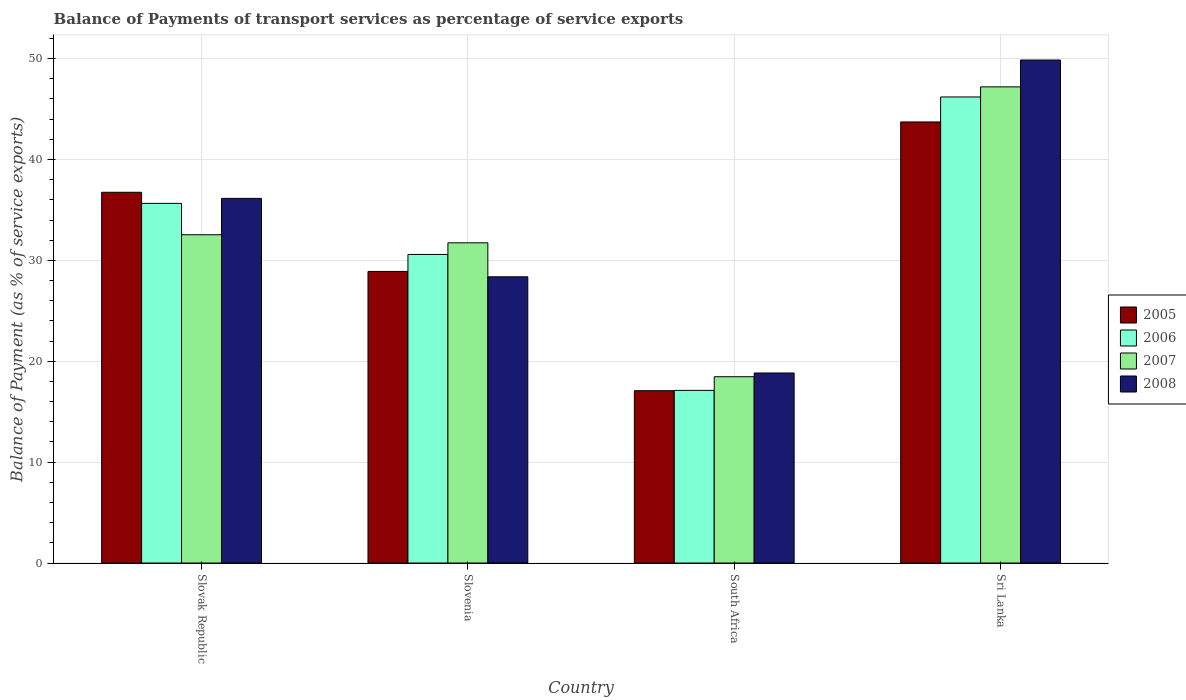How many different coloured bars are there?
Provide a succinct answer. 4. How many groups of bars are there?
Your answer should be compact. 4. What is the label of the 2nd group of bars from the left?
Your answer should be compact. Slovenia. In how many cases, is the number of bars for a given country not equal to the number of legend labels?
Offer a very short reply. 0. What is the balance of payments of transport services in 2005 in Sri Lanka?
Keep it short and to the point. 43.72. Across all countries, what is the maximum balance of payments of transport services in 2006?
Give a very brief answer. 46.2. Across all countries, what is the minimum balance of payments of transport services in 2005?
Your answer should be very brief. 17.08. In which country was the balance of payments of transport services in 2006 maximum?
Your response must be concise. Sri Lanka. In which country was the balance of payments of transport services in 2006 minimum?
Your answer should be compact. South Africa. What is the total balance of payments of transport services in 2007 in the graph?
Offer a very short reply. 129.95. What is the difference between the balance of payments of transport services in 2007 in Slovenia and that in South Africa?
Offer a very short reply. 13.27. What is the difference between the balance of payments of transport services in 2007 in Slovenia and the balance of payments of transport services in 2006 in Slovak Republic?
Make the answer very short. -3.91. What is the average balance of payments of transport services in 2006 per country?
Offer a terse response. 32.39. What is the difference between the balance of payments of transport services of/in 2008 and balance of payments of transport services of/in 2005 in Sri Lanka?
Ensure brevity in your answer.  6.14. In how many countries, is the balance of payments of transport services in 2008 greater than 16 %?
Your answer should be compact. 4. What is the ratio of the balance of payments of transport services in 2005 in Slovak Republic to that in South Africa?
Provide a succinct answer. 2.15. Is the balance of payments of transport services in 2007 in South Africa less than that in Sri Lanka?
Your answer should be compact. Yes. What is the difference between the highest and the second highest balance of payments of transport services in 2005?
Offer a very short reply. 6.97. What is the difference between the highest and the lowest balance of payments of transport services in 2007?
Your response must be concise. 28.73. In how many countries, is the balance of payments of transport services in 2008 greater than the average balance of payments of transport services in 2008 taken over all countries?
Your answer should be very brief. 2. Is the sum of the balance of payments of transport services in 2008 in Slovak Republic and Sri Lanka greater than the maximum balance of payments of transport services in 2005 across all countries?
Offer a terse response. Yes. Is it the case that in every country, the sum of the balance of payments of transport services in 2005 and balance of payments of transport services in 2008 is greater than the sum of balance of payments of transport services in 2006 and balance of payments of transport services in 2007?
Provide a succinct answer. No. What does the 1st bar from the left in Slovak Republic represents?
Ensure brevity in your answer.  2005. What does the 2nd bar from the right in Slovak Republic represents?
Your response must be concise. 2007. Is it the case that in every country, the sum of the balance of payments of transport services in 2006 and balance of payments of transport services in 2005 is greater than the balance of payments of transport services in 2008?
Your answer should be very brief. Yes. Does the graph contain any zero values?
Ensure brevity in your answer.  No. Where does the legend appear in the graph?
Keep it short and to the point. Center right. How many legend labels are there?
Offer a very short reply. 4. What is the title of the graph?
Your response must be concise. Balance of Payments of transport services as percentage of service exports. What is the label or title of the Y-axis?
Make the answer very short. Balance of Payment (as % of service exports). What is the Balance of Payment (as % of service exports) of 2005 in Slovak Republic?
Give a very brief answer. 36.75. What is the Balance of Payment (as % of service exports) in 2006 in Slovak Republic?
Offer a very short reply. 35.65. What is the Balance of Payment (as % of service exports) of 2007 in Slovak Republic?
Provide a succinct answer. 32.54. What is the Balance of Payment (as % of service exports) of 2008 in Slovak Republic?
Ensure brevity in your answer.  36.14. What is the Balance of Payment (as % of service exports) of 2005 in Slovenia?
Your answer should be very brief. 28.9. What is the Balance of Payment (as % of service exports) of 2006 in Slovenia?
Give a very brief answer. 30.59. What is the Balance of Payment (as % of service exports) in 2007 in Slovenia?
Make the answer very short. 31.74. What is the Balance of Payment (as % of service exports) of 2008 in Slovenia?
Ensure brevity in your answer.  28.37. What is the Balance of Payment (as % of service exports) in 2005 in South Africa?
Provide a succinct answer. 17.08. What is the Balance of Payment (as % of service exports) in 2006 in South Africa?
Give a very brief answer. 17.11. What is the Balance of Payment (as % of service exports) in 2007 in South Africa?
Give a very brief answer. 18.47. What is the Balance of Payment (as % of service exports) of 2008 in South Africa?
Provide a short and direct response. 18.84. What is the Balance of Payment (as % of service exports) of 2005 in Sri Lanka?
Keep it short and to the point. 43.72. What is the Balance of Payment (as % of service exports) of 2006 in Sri Lanka?
Offer a terse response. 46.2. What is the Balance of Payment (as % of service exports) of 2007 in Sri Lanka?
Ensure brevity in your answer.  47.2. What is the Balance of Payment (as % of service exports) in 2008 in Sri Lanka?
Give a very brief answer. 49.86. Across all countries, what is the maximum Balance of Payment (as % of service exports) in 2005?
Your response must be concise. 43.72. Across all countries, what is the maximum Balance of Payment (as % of service exports) in 2006?
Your answer should be compact. 46.2. Across all countries, what is the maximum Balance of Payment (as % of service exports) of 2007?
Provide a succinct answer. 47.2. Across all countries, what is the maximum Balance of Payment (as % of service exports) in 2008?
Provide a succinct answer. 49.86. Across all countries, what is the minimum Balance of Payment (as % of service exports) of 2005?
Offer a very short reply. 17.08. Across all countries, what is the minimum Balance of Payment (as % of service exports) of 2006?
Your response must be concise. 17.11. Across all countries, what is the minimum Balance of Payment (as % of service exports) in 2007?
Your answer should be compact. 18.47. Across all countries, what is the minimum Balance of Payment (as % of service exports) in 2008?
Provide a short and direct response. 18.84. What is the total Balance of Payment (as % of service exports) in 2005 in the graph?
Your response must be concise. 126.46. What is the total Balance of Payment (as % of service exports) in 2006 in the graph?
Ensure brevity in your answer.  129.55. What is the total Balance of Payment (as % of service exports) of 2007 in the graph?
Keep it short and to the point. 129.95. What is the total Balance of Payment (as % of service exports) in 2008 in the graph?
Your answer should be very brief. 133.21. What is the difference between the Balance of Payment (as % of service exports) in 2005 in Slovak Republic and that in Slovenia?
Your answer should be compact. 7.85. What is the difference between the Balance of Payment (as % of service exports) in 2006 in Slovak Republic and that in Slovenia?
Offer a very short reply. 5.06. What is the difference between the Balance of Payment (as % of service exports) of 2007 in Slovak Republic and that in Slovenia?
Offer a terse response. 0.8. What is the difference between the Balance of Payment (as % of service exports) in 2008 in Slovak Republic and that in Slovenia?
Give a very brief answer. 7.77. What is the difference between the Balance of Payment (as % of service exports) of 2005 in Slovak Republic and that in South Africa?
Keep it short and to the point. 19.67. What is the difference between the Balance of Payment (as % of service exports) of 2006 in Slovak Republic and that in South Africa?
Provide a short and direct response. 18.54. What is the difference between the Balance of Payment (as % of service exports) of 2007 in Slovak Republic and that in South Africa?
Give a very brief answer. 14.07. What is the difference between the Balance of Payment (as % of service exports) in 2008 in Slovak Republic and that in South Africa?
Offer a very short reply. 17.31. What is the difference between the Balance of Payment (as % of service exports) in 2005 in Slovak Republic and that in Sri Lanka?
Your answer should be very brief. -6.97. What is the difference between the Balance of Payment (as % of service exports) in 2006 in Slovak Republic and that in Sri Lanka?
Offer a terse response. -10.55. What is the difference between the Balance of Payment (as % of service exports) in 2007 in Slovak Republic and that in Sri Lanka?
Keep it short and to the point. -14.66. What is the difference between the Balance of Payment (as % of service exports) of 2008 in Slovak Republic and that in Sri Lanka?
Your response must be concise. -13.72. What is the difference between the Balance of Payment (as % of service exports) in 2005 in Slovenia and that in South Africa?
Give a very brief answer. 11.82. What is the difference between the Balance of Payment (as % of service exports) in 2006 in Slovenia and that in South Africa?
Keep it short and to the point. 13.47. What is the difference between the Balance of Payment (as % of service exports) of 2007 in Slovenia and that in South Africa?
Ensure brevity in your answer.  13.27. What is the difference between the Balance of Payment (as % of service exports) in 2008 in Slovenia and that in South Africa?
Your response must be concise. 9.53. What is the difference between the Balance of Payment (as % of service exports) in 2005 in Slovenia and that in Sri Lanka?
Provide a succinct answer. -14.82. What is the difference between the Balance of Payment (as % of service exports) of 2006 in Slovenia and that in Sri Lanka?
Keep it short and to the point. -15.61. What is the difference between the Balance of Payment (as % of service exports) of 2007 in Slovenia and that in Sri Lanka?
Give a very brief answer. -15.46. What is the difference between the Balance of Payment (as % of service exports) of 2008 in Slovenia and that in Sri Lanka?
Your answer should be very brief. -21.49. What is the difference between the Balance of Payment (as % of service exports) of 2005 in South Africa and that in Sri Lanka?
Ensure brevity in your answer.  -26.64. What is the difference between the Balance of Payment (as % of service exports) in 2006 in South Africa and that in Sri Lanka?
Your answer should be compact. -29.09. What is the difference between the Balance of Payment (as % of service exports) in 2007 in South Africa and that in Sri Lanka?
Give a very brief answer. -28.73. What is the difference between the Balance of Payment (as % of service exports) in 2008 in South Africa and that in Sri Lanka?
Ensure brevity in your answer.  -31.02. What is the difference between the Balance of Payment (as % of service exports) in 2005 in Slovak Republic and the Balance of Payment (as % of service exports) in 2006 in Slovenia?
Make the answer very short. 6.16. What is the difference between the Balance of Payment (as % of service exports) in 2005 in Slovak Republic and the Balance of Payment (as % of service exports) in 2007 in Slovenia?
Your response must be concise. 5.01. What is the difference between the Balance of Payment (as % of service exports) in 2005 in Slovak Republic and the Balance of Payment (as % of service exports) in 2008 in Slovenia?
Give a very brief answer. 8.38. What is the difference between the Balance of Payment (as % of service exports) in 2006 in Slovak Republic and the Balance of Payment (as % of service exports) in 2007 in Slovenia?
Your response must be concise. 3.91. What is the difference between the Balance of Payment (as % of service exports) in 2006 in Slovak Republic and the Balance of Payment (as % of service exports) in 2008 in Slovenia?
Provide a short and direct response. 7.28. What is the difference between the Balance of Payment (as % of service exports) of 2007 in Slovak Republic and the Balance of Payment (as % of service exports) of 2008 in Slovenia?
Make the answer very short. 4.17. What is the difference between the Balance of Payment (as % of service exports) in 2005 in Slovak Republic and the Balance of Payment (as % of service exports) in 2006 in South Africa?
Provide a succinct answer. 19.64. What is the difference between the Balance of Payment (as % of service exports) of 2005 in Slovak Republic and the Balance of Payment (as % of service exports) of 2007 in South Africa?
Ensure brevity in your answer.  18.28. What is the difference between the Balance of Payment (as % of service exports) of 2005 in Slovak Republic and the Balance of Payment (as % of service exports) of 2008 in South Africa?
Provide a short and direct response. 17.91. What is the difference between the Balance of Payment (as % of service exports) in 2006 in Slovak Republic and the Balance of Payment (as % of service exports) in 2007 in South Africa?
Offer a terse response. 17.18. What is the difference between the Balance of Payment (as % of service exports) of 2006 in Slovak Republic and the Balance of Payment (as % of service exports) of 2008 in South Africa?
Provide a short and direct response. 16.81. What is the difference between the Balance of Payment (as % of service exports) in 2007 in Slovak Republic and the Balance of Payment (as % of service exports) in 2008 in South Africa?
Make the answer very short. 13.71. What is the difference between the Balance of Payment (as % of service exports) in 2005 in Slovak Republic and the Balance of Payment (as % of service exports) in 2006 in Sri Lanka?
Your answer should be compact. -9.45. What is the difference between the Balance of Payment (as % of service exports) of 2005 in Slovak Republic and the Balance of Payment (as % of service exports) of 2007 in Sri Lanka?
Make the answer very short. -10.45. What is the difference between the Balance of Payment (as % of service exports) of 2005 in Slovak Republic and the Balance of Payment (as % of service exports) of 2008 in Sri Lanka?
Your response must be concise. -13.11. What is the difference between the Balance of Payment (as % of service exports) of 2006 in Slovak Republic and the Balance of Payment (as % of service exports) of 2007 in Sri Lanka?
Make the answer very short. -11.55. What is the difference between the Balance of Payment (as % of service exports) of 2006 in Slovak Republic and the Balance of Payment (as % of service exports) of 2008 in Sri Lanka?
Provide a succinct answer. -14.21. What is the difference between the Balance of Payment (as % of service exports) of 2007 in Slovak Republic and the Balance of Payment (as % of service exports) of 2008 in Sri Lanka?
Offer a very short reply. -17.32. What is the difference between the Balance of Payment (as % of service exports) in 2005 in Slovenia and the Balance of Payment (as % of service exports) in 2006 in South Africa?
Make the answer very short. 11.79. What is the difference between the Balance of Payment (as % of service exports) in 2005 in Slovenia and the Balance of Payment (as % of service exports) in 2007 in South Africa?
Offer a very short reply. 10.44. What is the difference between the Balance of Payment (as % of service exports) in 2005 in Slovenia and the Balance of Payment (as % of service exports) in 2008 in South Africa?
Make the answer very short. 10.07. What is the difference between the Balance of Payment (as % of service exports) of 2006 in Slovenia and the Balance of Payment (as % of service exports) of 2007 in South Africa?
Your answer should be compact. 12.12. What is the difference between the Balance of Payment (as % of service exports) in 2006 in Slovenia and the Balance of Payment (as % of service exports) in 2008 in South Africa?
Make the answer very short. 11.75. What is the difference between the Balance of Payment (as % of service exports) of 2007 in Slovenia and the Balance of Payment (as % of service exports) of 2008 in South Africa?
Provide a short and direct response. 12.9. What is the difference between the Balance of Payment (as % of service exports) in 2005 in Slovenia and the Balance of Payment (as % of service exports) in 2006 in Sri Lanka?
Offer a terse response. -17.3. What is the difference between the Balance of Payment (as % of service exports) of 2005 in Slovenia and the Balance of Payment (as % of service exports) of 2007 in Sri Lanka?
Ensure brevity in your answer.  -18.3. What is the difference between the Balance of Payment (as % of service exports) in 2005 in Slovenia and the Balance of Payment (as % of service exports) in 2008 in Sri Lanka?
Provide a succinct answer. -20.96. What is the difference between the Balance of Payment (as % of service exports) of 2006 in Slovenia and the Balance of Payment (as % of service exports) of 2007 in Sri Lanka?
Ensure brevity in your answer.  -16.61. What is the difference between the Balance of Payment (as % of service exports) in 2006 in Slovenia and the Balance of Payment (as % of service exports) in 2008 in Sri Lanka?
Make the answer very short. -19.27. What is the difference between the Balance of Payment (as % of service exports) in 2007 in Slovenia and the Balance of Payment (as % of service exports) in 2008 in Sri Lanka?
Keep it short and to the point. -18.12. What is the difference between the Balance of Payment (as % of service exports) in 2005 in South Africa and the Balance of Payment (as % of service exports) in 2006 in Sri Lanka?
Your answer should be very brief. -29.12. What is the difference between the Balance of Payment (as % of service exports) of 2005 in South Africa and the Balance of Payment (as % of service exports) of 2007 in Sri Lanka?
Your response must be concise. -30.12. What is the difference between the Balance of Payment (as % of service exports) in 2005 in South Africa and the Balance of Payment (as % of service exports) in 2008 in Sri Lanka?
Give a very brief answer. -32.78. What is the difference between the Balance of Payment (as % of service exports) in 2006 in South Africa and the Balance of Payment (as % of service exports) in 2007 in Sri Lanka?
Offer a terse response. -30.09. What is the difference between the Balance of Payment (as % of service exports) in 2006 in South Africa and the Balance of Payment (as % of service exports) in 2008 in Sri Lanka?
Provide a short and direct response. -32.75. What is the difference between the Balance of Payment (as % of service exports) of 2007 in South Africa and the Balance of Payment (as % of service exports) of 2008 in Sri Lanka?
Offer a terse response. -31.39. What is the average Balance of Payment (as % of service exports) in 2005 per country?
Provide a succinct answer. 31.61. What is the average Balance of Payment (as % of service exports) in 2006 per country?
Give a very brief answer. 32.39. What is the average Balance of Payment (as % of service exports) of 2007 per country?
Provide a succinct answer. 32.49. What is the average Balance of Payment (as % of service exports) of 2008 per country?
Keep it short and to the point. 33.3. What is the difference between the Balance of Payment (as % of service exports) in 2005 and Balance of Payment (as % of service exports) in 2006 in Slovak Republic?
Ensure brevity in your answer.  1.1. What is the difference between the Balance of Payment (as % of service exports) in 2005 and Balance of Payment (as % of service exports) in 2007 in Slovak Republic?
Give a very brief answer. 4.21. What is the difference between the Balance of Payment (as % of service exports) of 2005 and Balance of Payment (as % of service exports) of 2008 in Slovak Republic?
Offer a very short reply. 0.6. What is the difference between the Balance of Payment (as % of service exports) in 2006 and Balance of Payment (as % of service exports) in 2007 in Slovak Republic?
Ensure brevity in your answer.  3.11. What is the difference between the Balance of Payment (as % of service exports) of 2006 and Balance of Payment (as % of service exports) of 2008 in Slovak Republic?
Provide a short and direct response. -0.49. What is the difference between the Balance of Payment (as % of service exports) in 2007 and Balance of Payment (as % of service exports) in 2008 in Slovak Republic?
Make the answer very short. -3.6. What is the difference between the Balance of Payment (as % of service exports) in 2005 and Balance of Payment (as % of service exports) in 2006 in Slovenia?
Your answer should be very brief. -1.69. What is the difference between the Balance of Payment (as % of service exports) in 2005 and Balance of Payment (as % of service exports) in 2007 in Slovenia?
Give a very brief answer. -2.84. What is the difference between the Balance of Payment (as % of service exports) of 2005 and Balance of Payment (as % of service exports) of 2008 in Slovenia?
Your response must be concise. 0.53. What is the difference between the Balance of Payment (as % of service exports) of 2006 and Balance of Payment (as % of service exports) of 2007 in Slovenia?
Offer a very short reply. -1.15. What is the difference between the Balance of Payment (as % of service exports) of 2006 and Balance of Payment (as % of service exports) of 2008 in Slovenia?
Ensure brevity in your answer.  2.22. What is the difference between the Balance of Payment (as % of service exports) in 2007 and Balance of Payment (as % of service exports) in 2008 in Slovenia?
Offer a very short reply. 3.37. What is the difference between the Balance of Payment (as % of service exports) in 2005 and Balance of Payment (as % of service exports) in 2006 in South Africa?
Offer a very short reply. -0.03. What is the difference between the Balance of Payment (as % of service exports) in 2005 and Balance of Payment (as % of service exports) in 2007 in South Africa?
Your answer should be very brief. -1.38. What is the difference between the Balance of Payment (as % of service exports) of 2005 and Balance of Payment (as % of service exports) of 2008 in South Africa?
Ensure brevity in your answer.  -1.75. What is the difference between the Balance of Payment (as % of service exports) of 2006 and Balance of Payment (as % of service exports) of 2007 in South Africa?
Keep it short and to the point. -1.35. What is the difference between the Balance of Payment (as % of service exports) in 2006 and Balance of Payment (as % of service exports) in 2008 in South Africa?
Make the answer very short. -1.72. What is the difference between the Balance of Payment (as % of service exports) of 2007 and Balance of Payment (as % of service exports) of 2008 in South Africa?
Your response must be concise. -0.37. What is the difference between the Balance of Payment (as % of service exports) in 2005 and Balance of Payment (as % of service exports) in 2006 in Sri Lanka?
Make the answer very short. -2.48. What is the difference between the Balance of Payment (as % of service exports) in 2005 and Balance of Payment (as % of service exports) in 2007 in Sri Lanka?
Keep it short and to the point. -3.48. What is the difference between the Balance of Payment (as % of service exports) in 2005 and Balance of Payment (as % of service exports) in 2008 in Sri Lanka?
Provide a short and direct response. -6.14. What is the difference between the Balance of Payment (as % of service exports) in 2006 and Balance of Payment (as % of service exports) in 2007 in Sri Lanka?
Provide a succinct answer. -1. What is the difference between the Balance of Payment (as % of service exports) in 2006 and Balance of Payment (as % of service exports) in 2008 in Sri Lanka?
Ensure brevity in your answer.  -3.66. What is the difference between the Balance of Payment (as % of service exports) of 2007 and Balance of Payment (as % of service exports) of 2008 in Sri Lanka?
Your response must be concise. -2.66. What is the ratio of the Balance of Payment (as % of service exports) of 2005 in Slovak Republic to that in Slovenia?
Provide a short and direct response. 1.27. What is the ratio of the Balance of Payment (as % of service exports) in 2006 in Slovak Republic to that in Slovenia?
Make the answer very short. 1.17. What is the ratio of the Balance of Payment (as % of service exports) of 2007 in Slovak Republic to that in Slovenia?
Your response must be concise. 1.03. What is the ratio of the Balance of Payment (as % of service exports) in 2008 in Slovak Republic to that in Slovenia?
Your answer should be compact. 1.27. What is the ratio of the Balance of Payment (as % of service exports) in 2005 in Slovak Republic to that in South Africa?
Ensure brevity in your answer.  2.15. What is the ratio of the Balance of Payment (as % of service exports) of 2006 in Slovak Republic to that in South Africa?
Provide a short and direct response. 2.08. What is the ratio of the Balance of Payment (as % of service exports) in 2007 in Slovak Republic to that in South Africa?
Offer a very short reply. 1.76. What is the ratio of the Balance of Payment (as % of service exports) of 2008 in Slovak Republic to that in South Africa?
Your answer should be compact. 1.92. What is the ratio of the Balance of Payment (as % of service exports) of 2005 in Slovak Republic to that in Sri Lanka?
Your response must be concise. 0.84. What is the ratio of the Balance of Payment (as % of service exports) of 2006 in Slovak Republic to that in Sri Lanka?
Ensure brevity in your answer.  0.77. What is the ratio of the Balance of Payment (as % of service exports) of 2007 in Slovak Republic to that in Sri Lanka?
Your response must be concise. 0.69. What is the ratio of the Balance of Payment (as % of service exports) of 2008 in Slovak Republic to that in Sri Lanka?
Your answer should be very brief. 0.72. What is the ratio of the Balance of Payment (as % of service exports) in 2005 in Slovenia to that in South Africa?
Offer a terse response. 1.69. What is the ratio of the Balance of Payment (as % of service exports) in 2006 in Slovenia to that in South Africa?
Provide a succinct answer. 1.79. What is the ratio of the Balance of Payment (as % of service exports) of 2007 in Slovenia to that in South Africa?
Ensure brevity in your answer.  1.72. What is the ratio of the Balance of Payment (as % of service exports) of 2008 in Slovenia to that in South Africa?
Your answer should be very brief. 1.51. What is the ratio of the Balance of Payment (as % of service exports) in 2005 in Slovenia to that in Sri Lanka?
Your response must be concise. 0.66. What is the ratio of the Balance of Payment (as % of service exports) in 2006 in Slovenia to that in Sri Lanka?
Provide a short and direct response. 0.66. What is the ratio of the Balance of Payment (as % of service exports) in 2007 in Slovenia to that in Sri Lanka?
Offer a very short reply. 0.67. What is the ratio of the Balance of Payment (as % of service exports) in 2008 in Slovenia to that in Sri Lanka?
Keep it short and to the point. 0.57. What is the ratio of the Balance of Payment (as % of service exports) in 2005 in South Africa to that in Sri Lanka?
Give a very brief answer. 0.39. What is the ratio of the Balance of Payment (as % of service exports) of 2006 in South Africa to that in Sri Lanka?
Your answer should be very brief. 0.37. What is the ratio of the Balance of Payment (as % of service exports) in 2007 in South Africa to that in Sri Lanka?
Provide a short and direct response. 0.39. What is the ratio of the Balance of Payment (as % of service exports) of 2008 in South Africa to that in Sri Lanka?
Your answer should be very brief. 0.38. What is the difference between the highest and the second highest Balance of Payment (as % of service exports) of 2005?
Your response must be concise. 6.97. What is the difference between the highest and the second highest Balance of Payment (as % of service exports) of 2006?
Provide a succinct answer. 10.55. What is the difference between the highest and the second highest Balance of Payment (as % of service exports) in 2007?
Give a very brief answer. 14.66. What is the difference between the highest and the second highest Balance of Payment (as % of service exports) in 2008?
Your response must be concise. 13.72. What is the difference between the highest and the lowest Balance of Payment (as % of service exports) of 2005?
Keep it short and to the point. 26.64. What is the difference between the highest and the lowest Balance of Payment (as % of service exports) of 2006?
Your response must be concise. 29.09. What is the difference between the highest and the lowest Balance of Payment (as % of service exports) of 2007?
Your answer should be very brief. 28.73. What is the difference between the highest and the lowest Balance of Payment (as % of service exports) of 2008?
Make the answer very short. 31.02. 